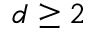Convert formula to latex. <formula><loc_0><loc_0><loc_500><loc_500>d \geq 2</formula> 